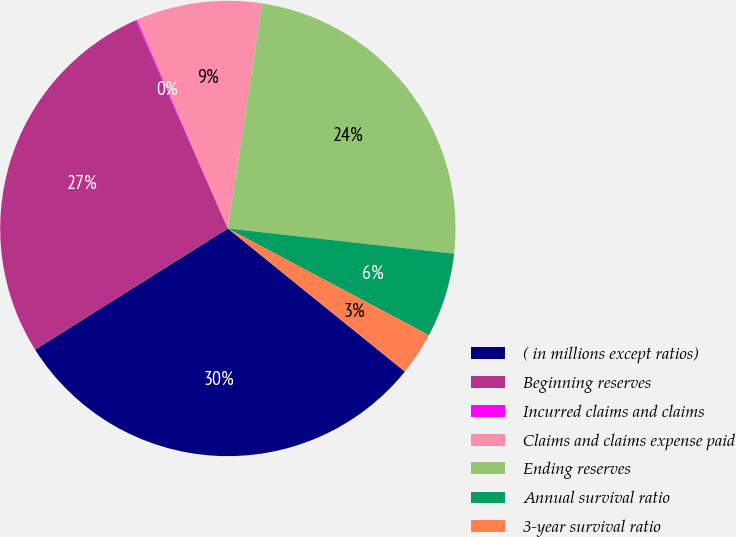Convert chart. <chart><loc_0><loc_0><loc_500><loc_500><pie_chart><fcel>( in millions except ratios)<fcel>Beginning reserves<fcel>Incurred claims and claims<fcel>Claims and claims expense paid<fcel>Ending reserves<fcel>Annual survival ratio<fcel>3-year survival ratio<nl><fcel>30.25%<fcel>27.3%<fcel>0.1%<fcel>8.95%<fcel>24.35%<fcel>6.0%<fcel>3.05%<nl></chart> 